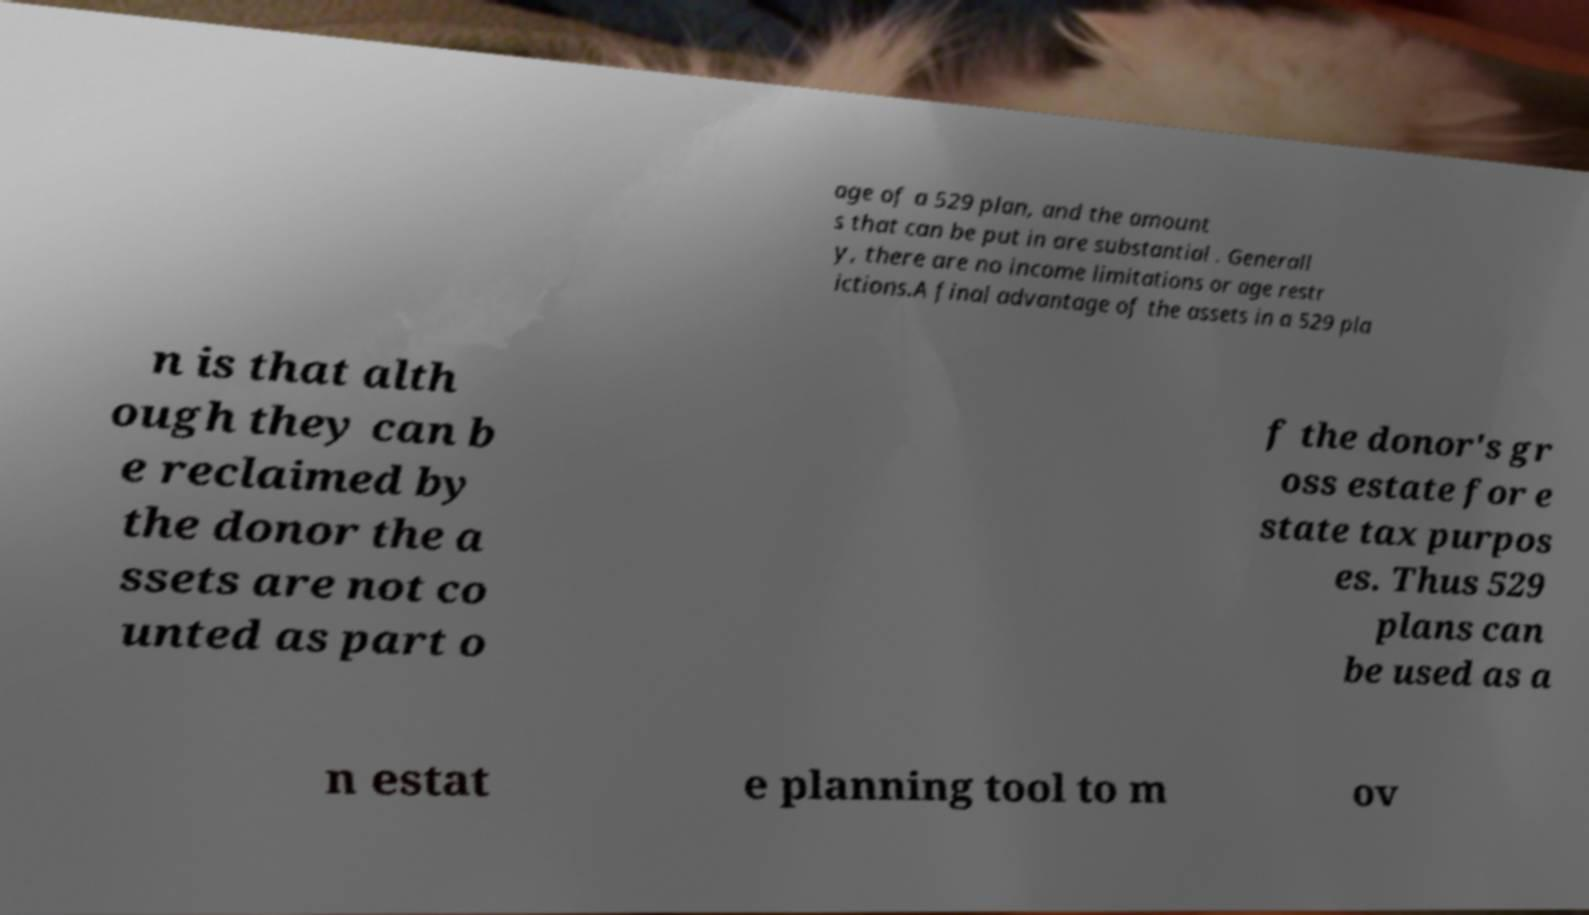What messages or text are displayed in this image? I need them in a readable, typed format. age of a 529 plan, and the amount s that can be put in are substantial . Generall y, there are no income limitations or age restr ictions.A final advantage of the assets in a 529 pla n is that alth ough they can b e reclaimed by the donor the a ssets are not co unted as part o f the donor's gr oss estate for e state tax purpos es. Thus 529 plans can be used as a n estat e planning tool to m ov 